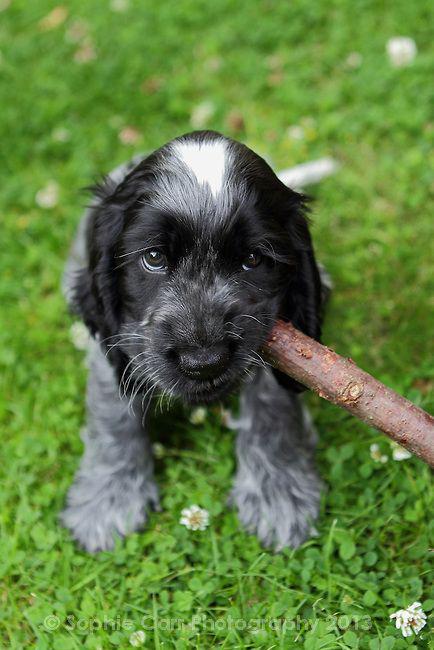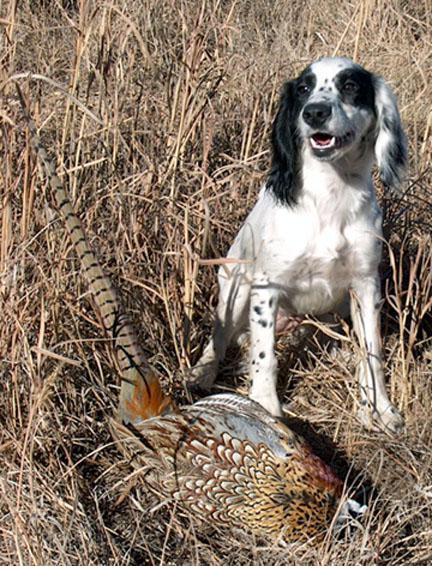The first image is the image on the left, the second image is the image on the right. Analyze the images presented: Is the assertion "The dog in the image on the left is lying on the grass." valid? Answer yes or no. Yes. The first image is the image on the left, the second image is the image on the right. Examine the images to the left and right. Is the description "An image shows one dog interacting with a stick-shaped item that is at least partly brown." accurate? Answer yes or no. Yes. 